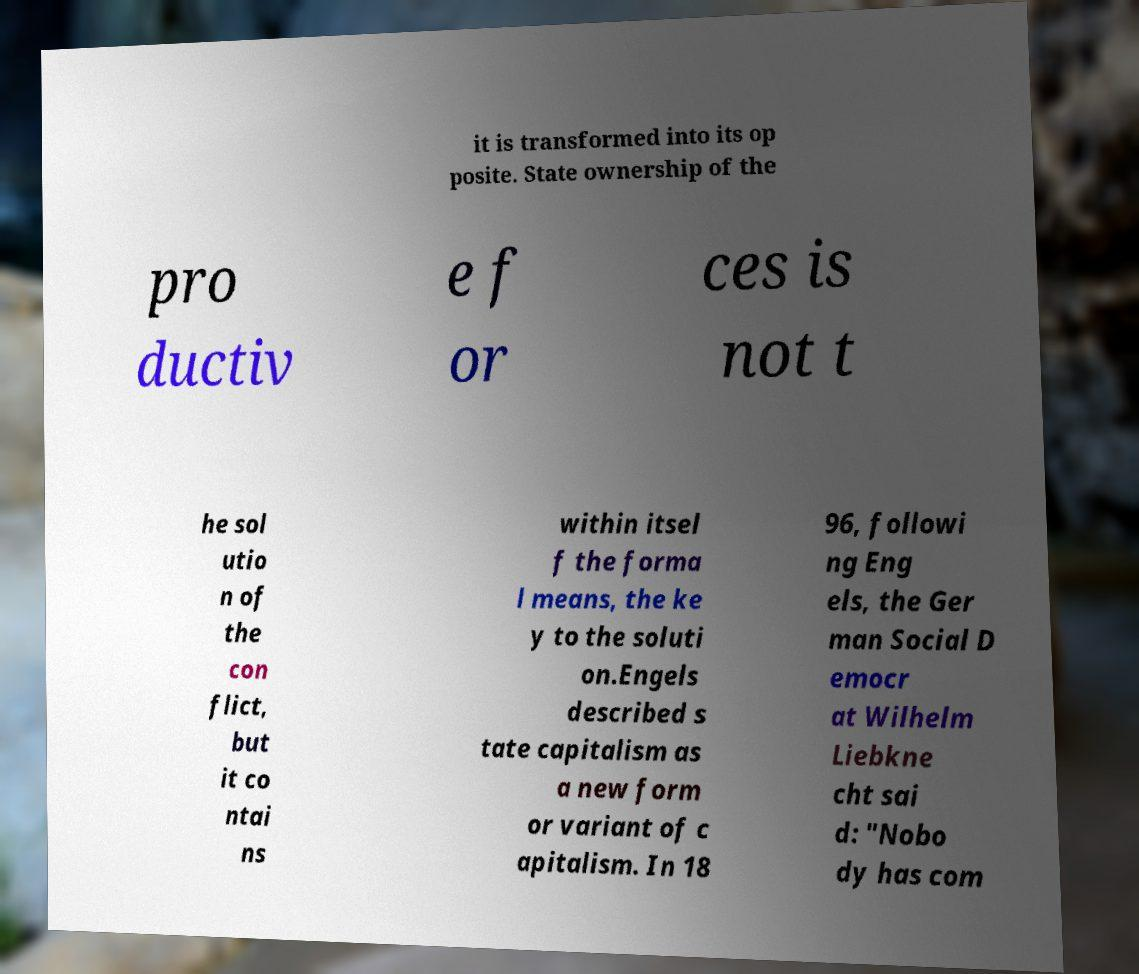Please read and relay the text visible in this image. What does it say? it is transformed into its op posite. State ownership of the pro ductiv e f or ces is not t he sol utio n of the con flict, but it co ntai ns within itsel f the forma l means, the ke y to the soluti on.Engels described s tate capitalism as a new form or variant of c apitalism. In 18 96, followi ng Eng els, the Ger man Social D emocr at Wilhelm Liebkne cht sai d: "Nobo dy has com 